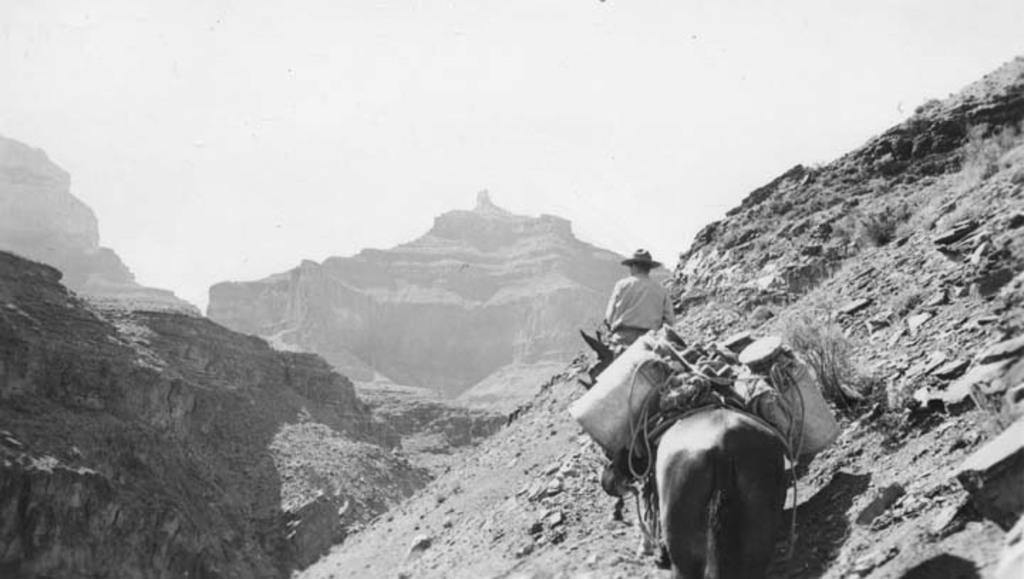Could you give a brief overview of what you see in this image? This is a black and white image, in this image there is a man going on a horse and there is another on that there are some can, there are mountains and a sky. 